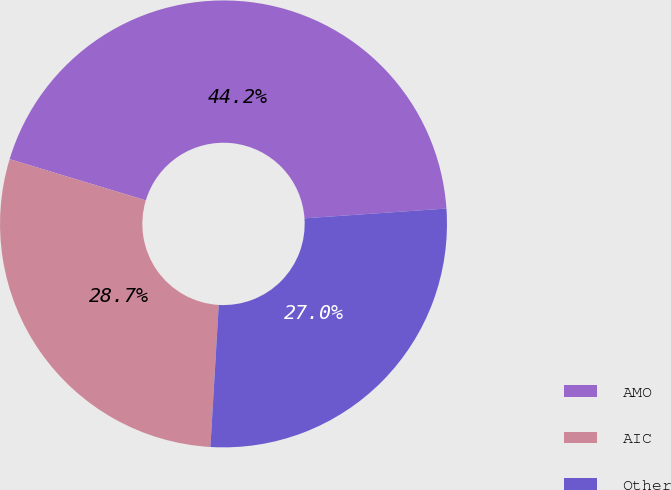Convert chart to OTSL. <chart><loc_0><loc_0><loc_500><loc_500><pie_chart><fcel>AMO<fcel>AIC<fcel>Other<nl><fcel>44.23%<fcel>28.75%<fcel>27.03%<nl></chart> 